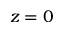<formula> <loc_0><loc_0><loc_500><loc_500>z = 0</formula> 